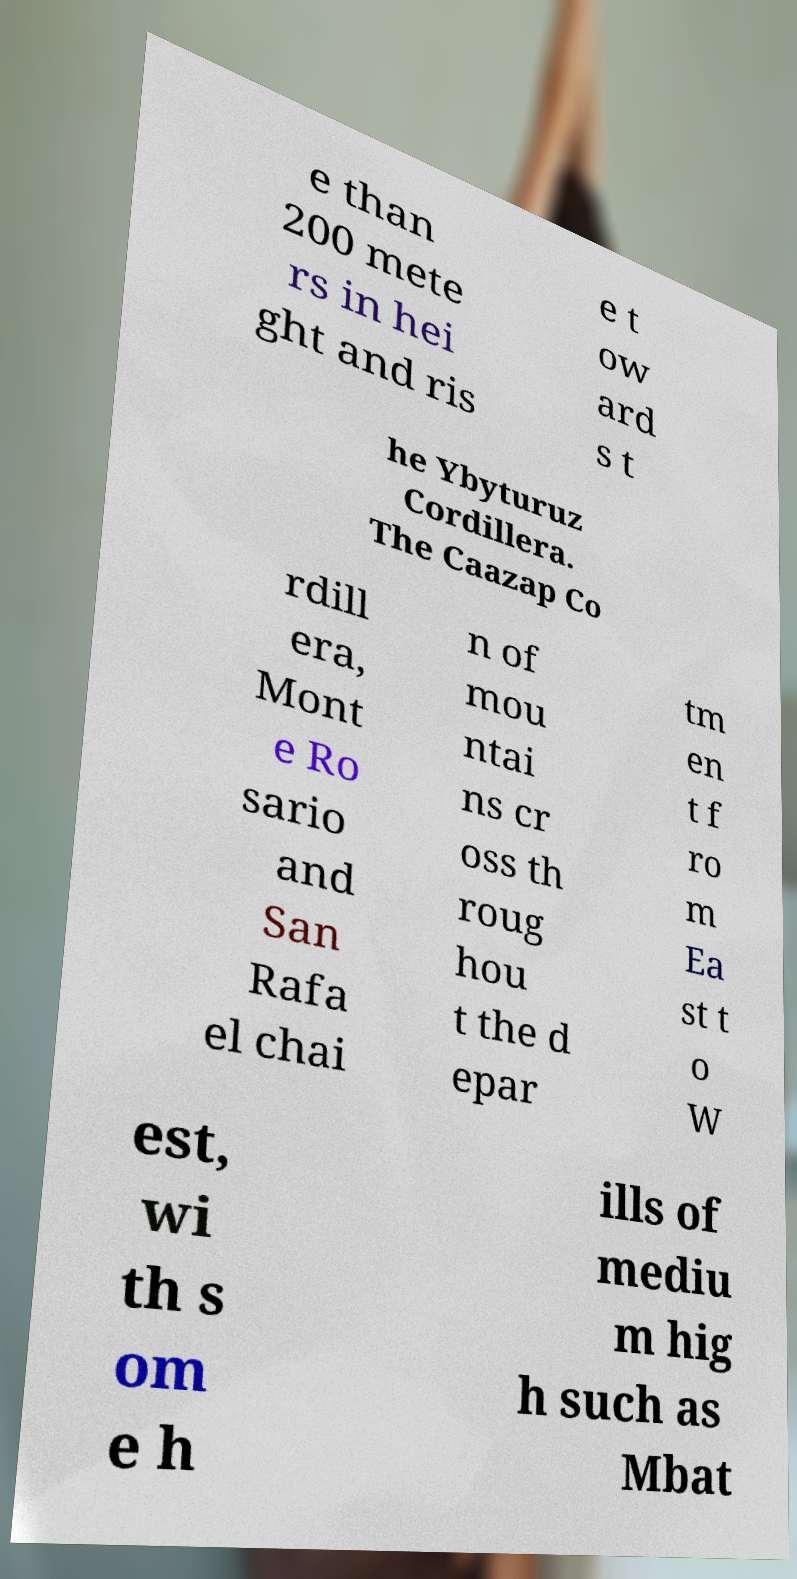For documentation purposes, I need the text within this image transcribed. Could you provide that? e than 200 mete rs in hei ght and ris e t ow ard s t he Ybyturuz Cordillera. The Caazap Co rdill era, Mont e Ro sario and San Rafa el chai n of mou ntai ns cr oss th roug hou t the d epar tm en t f ro m Ea st t o W est, wi th s om e h ills of mediu m hig h such as Mbat 